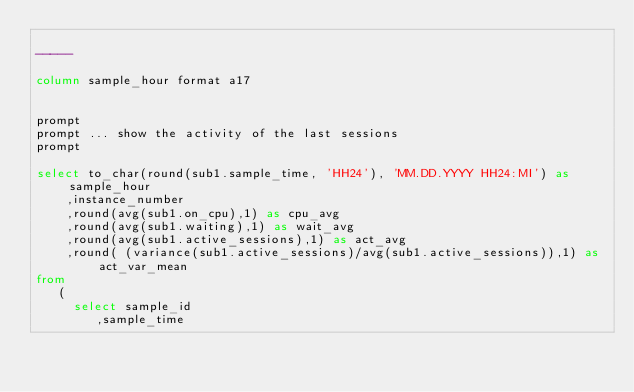Convert code to text. <code><loc_0><loc_0><loc_500><loc_500><_SQL_>
-----

column sample_hour format a17


prompt
prompt ... show the activity of the last sessions
prompt

select to_char(round(sub1.sample_time, 'HH24'), 'MM.DD.YYYY HH24:MI') as sample_hour
		,instance_number
		,round(avg(sub1.on_cpu),1) as cpu_avg
		,round(avg(sub1.waiting),1) as wait_avg
		,round(avg(sub1.active_sessions),1) as act_avg
		,round( (variance(sub1.active_sessions)/avg(sub1.active_sessions)),1) as act_var_mean
from
   ( 
     select sample_id
			  ,sample_time</code> 